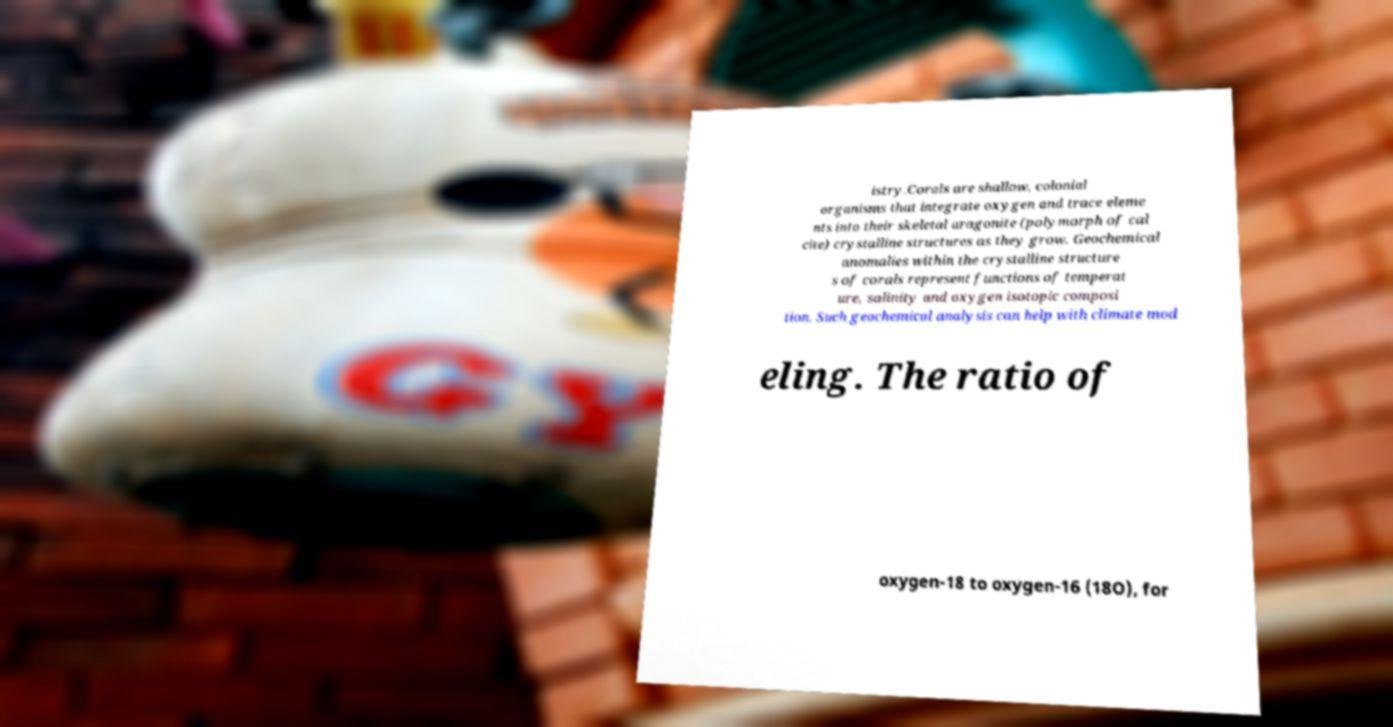I need the written content from this picture converted into text. Can you do that? istry.Corals are shallow, colonial organisms that integrate oxygen and trace eleme nts into their skeletal aragonite (polymorph of cal cite) crystalline structures as they grow. Geochemical anomalies within the crystalline structure s of corals represent functions of temperat ure, salinity and oxygen isotopic composi tion. Such geochemical analysis can help with climate mod eling. The ratio of oxygen-18 to oxygen-16 (18O), for 